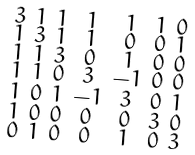<formula> <loc_0><loc_0><loc_500><loc_500>\begin{smallmatrix} 3 & 1 & 1 & 1 & 1 & 1 & 0 \\ 1 & 3 & 1 & 1 & 0 & 0 & 1 \\ 1 & 1 & 3 & 0 & 1 & 0 & 0 \\ 1 & 1 & 0 & 3 & - 1 & 0 & 0 \\ 1 & 0 & 1 & - 1 & 3 & 0 & 1 \\ 1 & 0 & 0 & 0 & 0 & 3 & 0 \\ 0 & 1 & 0 & 0 & 1 & 0 & 3 \end{smallmatrix}</formula> 